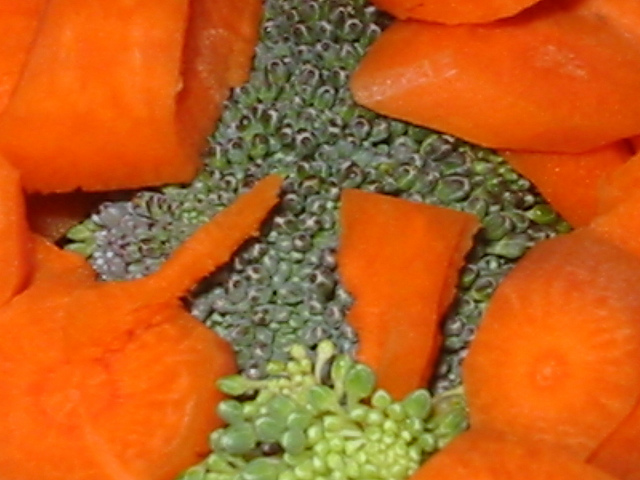<image>Can you eat this? I don't know if you can eat this. It depends on what it is. Can you eat this? I don't know if you can eat this. It can be both edible and non-edible. 